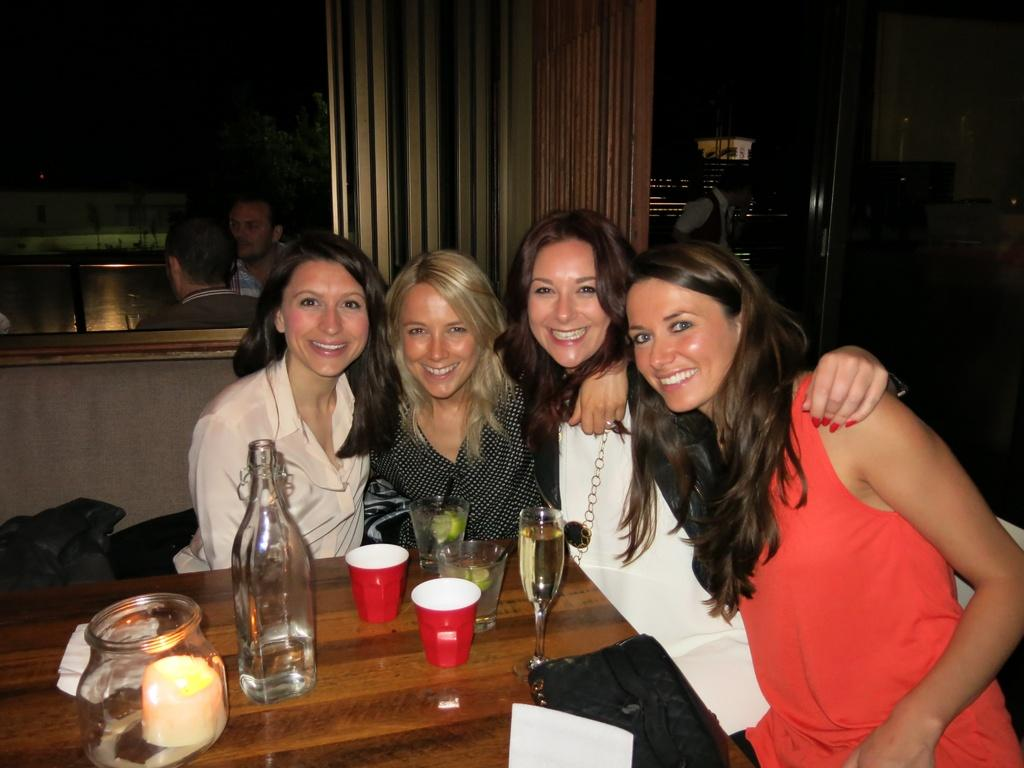How many women are in the image? There are four women in the image. What are the women doing in the image? The women are sitting on chairs and smiling. What is on the table in the image? There are wine glasses on the table. Are there any men in the image? Yes, there are two men in the background of the image. What are the men doing in the image? The men are sitting. What type of tools is the carpenter using in the image? There is no carpenter present in the image. What color is the underwear of the woman sitting on the left chair? The image does not show any underwear, so it cannot be determined. 